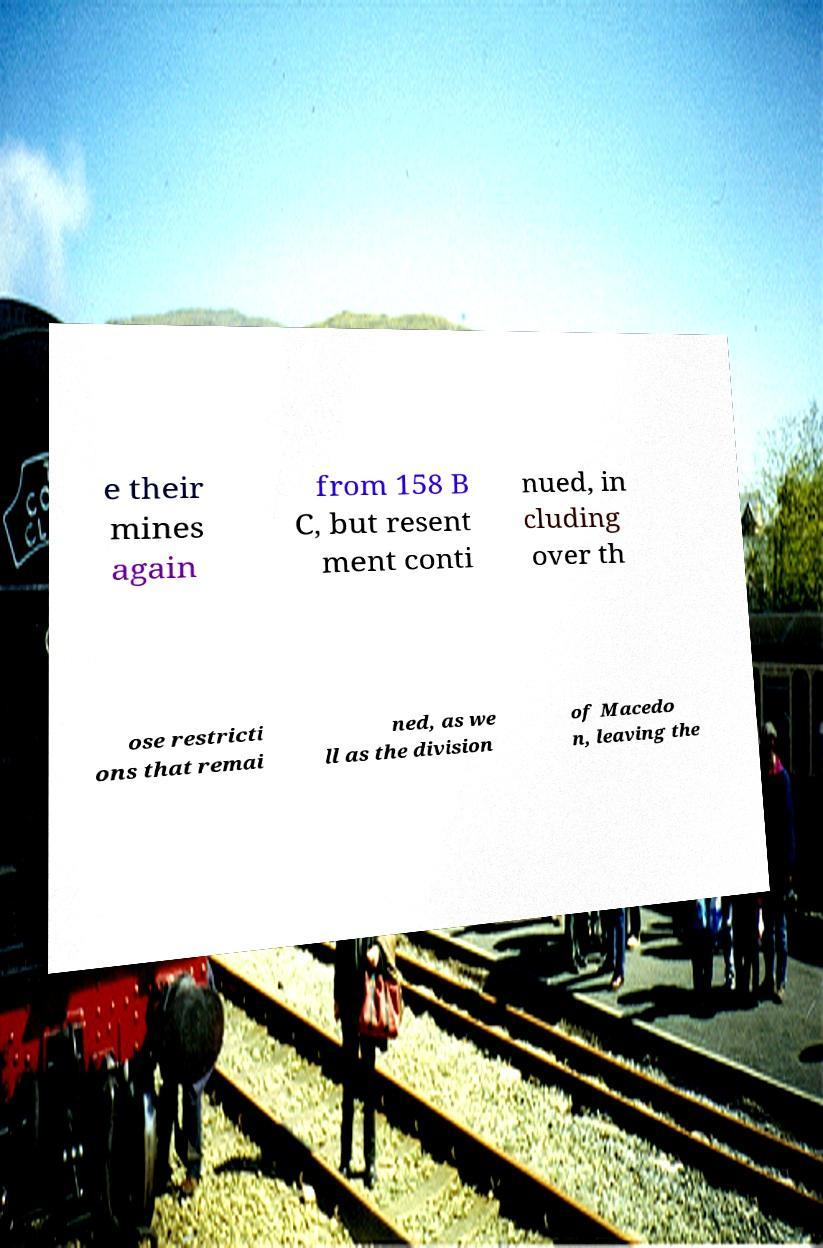Could you extract and type out the text from this image? e their mines again from 158 B C, but resent ment conti nued, in cluding over th ose restricti ons that remai ned, as we ll as the division of Macedo n, leaving the 